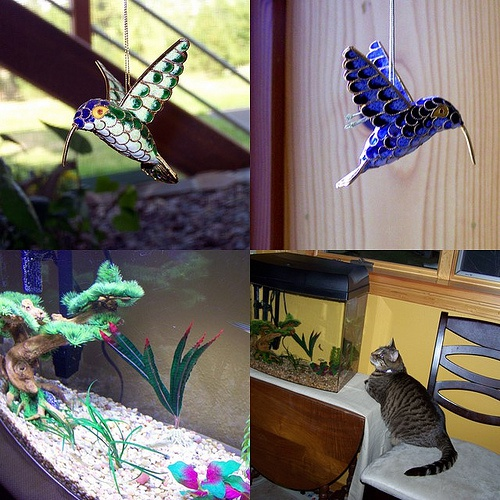Describe the objects in this image and their specific colors. I can see chair in black, darkgray, gray, and tan tones, bird in black, navy, darkblue, and gray tones, bird in black, ivory, gray, and darkgray tones, and cat in black and gray tones in this image. 